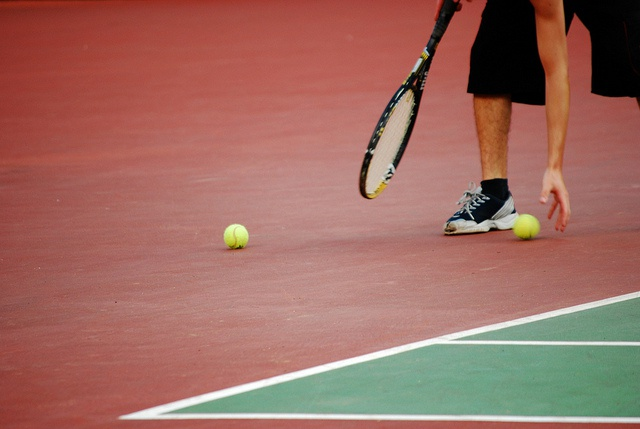Describe the objects in this image and their specific colors. I can see people in maroon, black, brown, and salmon tones, tennis racket in maroon, black, tan, and darkgray tones, sports ball in maroon, khaki, olive, and tan tones, and sports ball in maroon, khaki, olive, and tan tones in this image. 